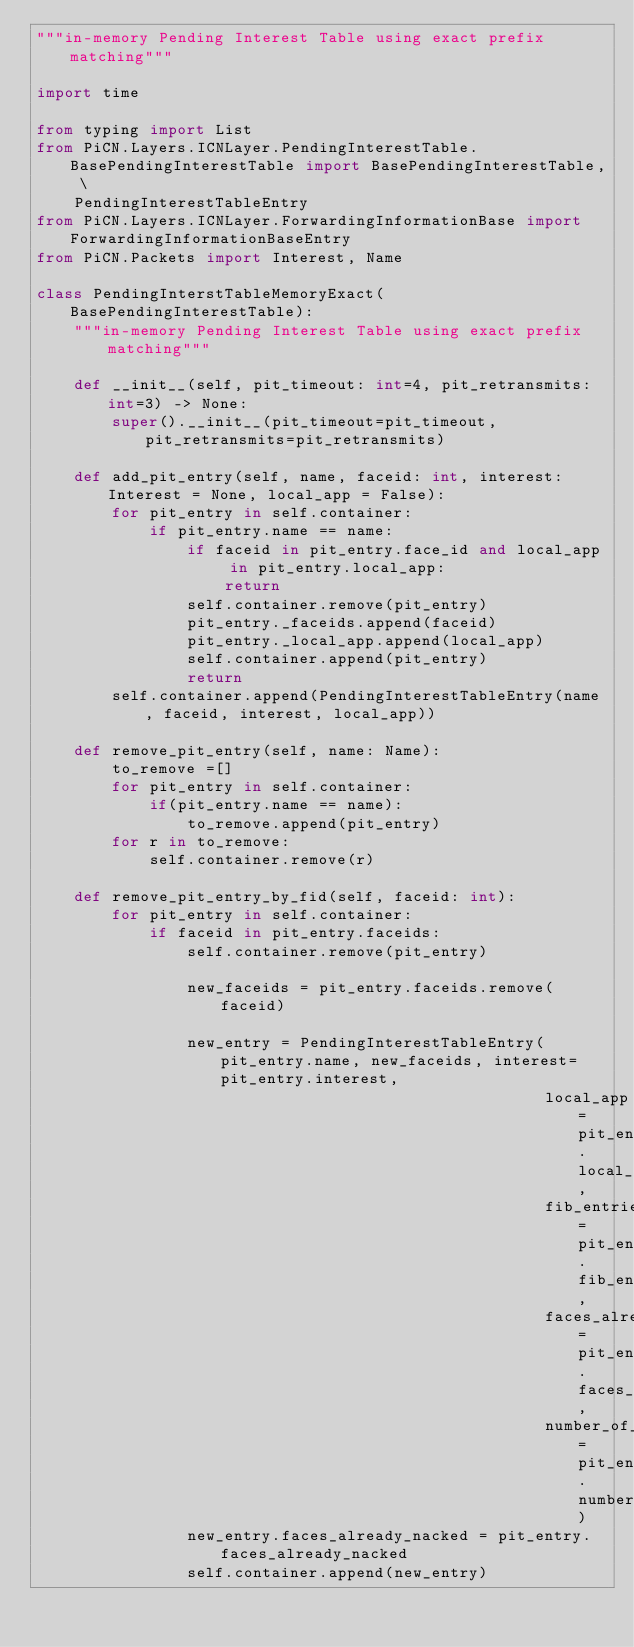Convert code to text. <code><loc_0><loc_0><loc_500><loc_500><_Python_>"""in-memory Pending Interest Table using exact prefix matching"""

import time

from typing import List
from PiCN.Layers.ICNLayer.PendingInterestTable.BasePendingInterestTable import BasePendingInterestTable, \
    PendingInterestTableEntry
from PiCN.Layers.ICNLayer.ForwardingInformationBase import ForwardingInformationBaseEntry
from PiCN.Packets import Interest, Name

class PendingInterstTableMemoryExact(BasePendingInterestTable):
    """in-memory Pending Interest Table using exact prefix matching"""

    def __init__(self, pit_timeout: int=4, pit_retransmits:int=3) -> None:
        super().__init__(pit_timeout=pit_timeout, pit_retransmits=pit_retransmits)

    def add_pit_entry(self, name, faceid: int, interest: Interest = None, local_app = False):
        for pit_entry in self.container:
            if pit_entry.name == name:
                if faceid in pit_entry.face_id and local_app in pit_entry.local_app:
                    return
                self.container.remove(pit_entry)
                pit_entry._faceids.append(faceid)
                pit_entry._local_app.append(local_app)
                self.container.append(pit_entry)
                return
        self.container.append(PendingInterestTableEntry(name, faceid, interest, local_app))

    def remove_pit_entry(self, name: Name):
        to_remove =[]
        for pit_entry in self.container:
            if(pit_entry.name == name):
                to_remove.append(pit_entry)
        for r in to_remove:
            self.container.remove(r)

    def remove_pit_entry_by_fid(self, faceid: int):
        for pit_entry in self.container:
            if faceid in pit_entry.faceids:
                self.container.remove(pit_entry)

                new_faceids = pit_entry.faceids.remove(faceid)

                new_entry = PendingInterestTableEntry(pit_entry.name, new_faceids, interest=pit_entry.interest,
                                                      local_app=pit_entry.local_app,
                                                      fib_entries_already_used=pit_entry.fib_entries_already_used,
                                                      faces_already_nacked=pit_entry.faces_already_nacked,
                                                      number_of_forwards=pit_entry.number_of_forwards)
                new_entry.faces_already_nacked = pit_entry.faces_already_nacked
                self.container.append(new_entry)

</code> 